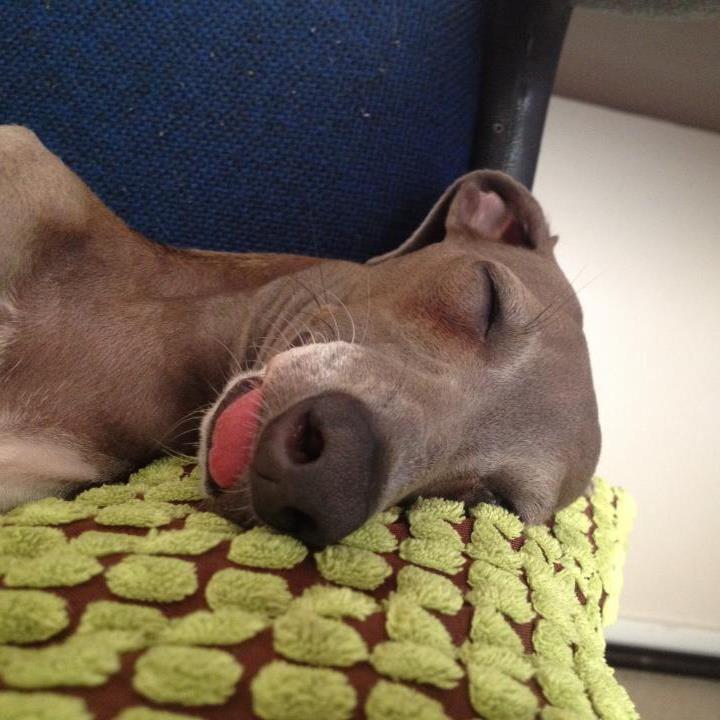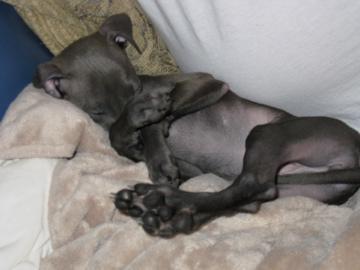The first image is the image on the left, the second image is the image on the right. For the images displayed, is the sentence "All dogs are sleeping." factually correct? Answer yes or no. Yes. 